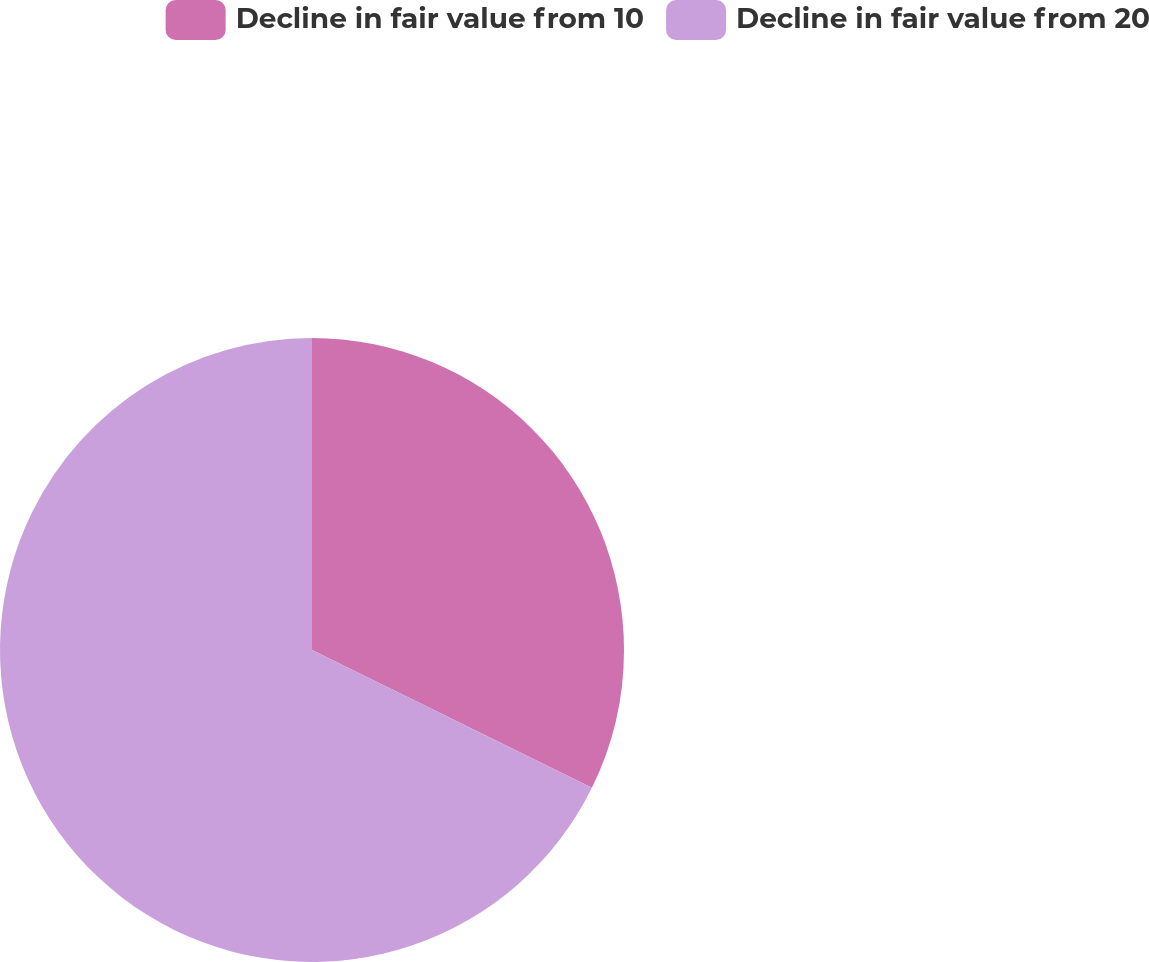Convert chart to OTSL. <chart><loc_0><loc_0><loc_500><loc_500><pie_chart><fcel>Decline in fair value from 10<fcel>Decline in fair value from 20<nl><fcel>32.28%<fcel>67.72%<nl></chart> 